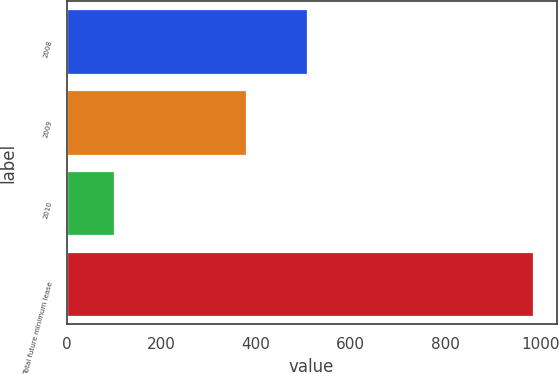Convert chart. <chart><loc_0><loc_0><loc_500><loc_500><bar_chart><fcel>2008<fcel>2009<fcel>2010<fcel>Total future minimum lease<nl><fcel>508<fcel>378<fcel>99<fcel>985<nl></chart> 